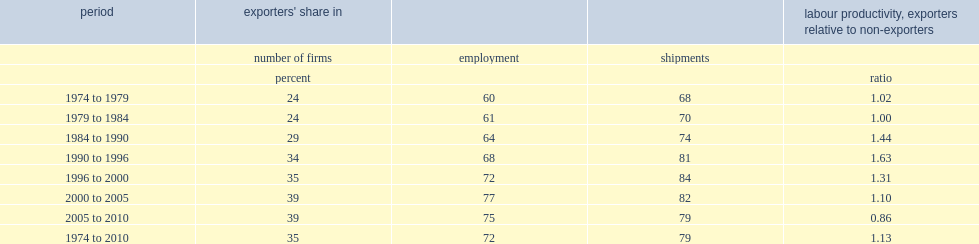Over the period from 1974 to 2010, what percent of canadian manufacturing firms were exporters? 35.0. How many percent of exporters was more productive than non-exporters? 0.13. 